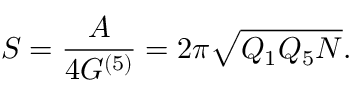<formula> <loc_0><loc_0><loc_500><loc_500>S = \frac { A } 4 G ^ { ( 5 ) } } = 2 \pi \sqrt { Q _ { 1 } Q _ { 5 } N } .</formula> 